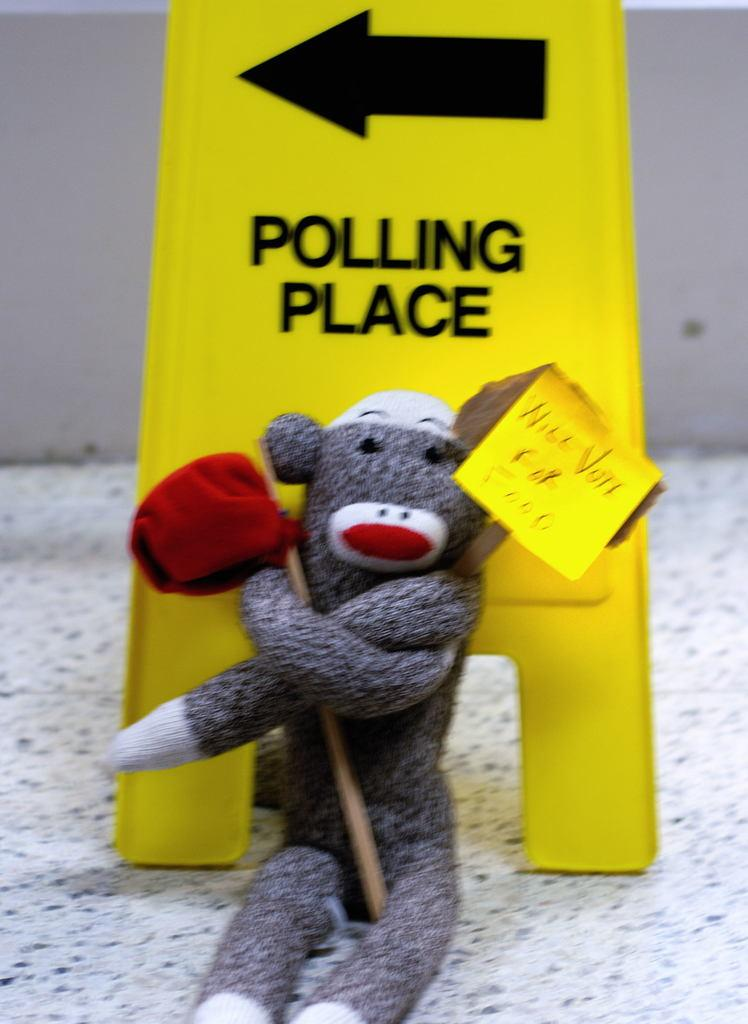What object is the main focus of the image? There is a toy in the image. What is located behind the toy? There is a directional board behind the toy. What is the lowest visible surface in the image? The image has a floor at the bottom. What is visible in the background of the image? There is a wall in the background of the image. Can you see any leaves falling from the roof in the image? There is no roof or leaves present in the image. 